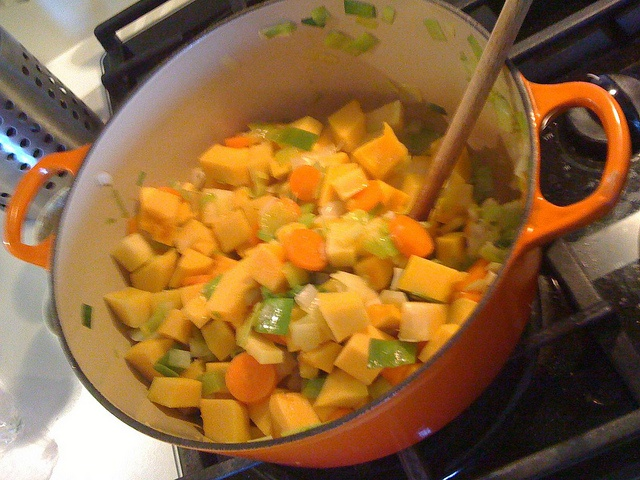Describe the objects in this image and their specific colors. I can see spoon in olive, brown, maroon, and gray tones, carrot in olive, red, orange, and brown tones, carrot in olive, orange, and maroon tones, carrot in olive, orange, and brown tones, and carrot in olive, red, orange, and maroon tones in this image. 